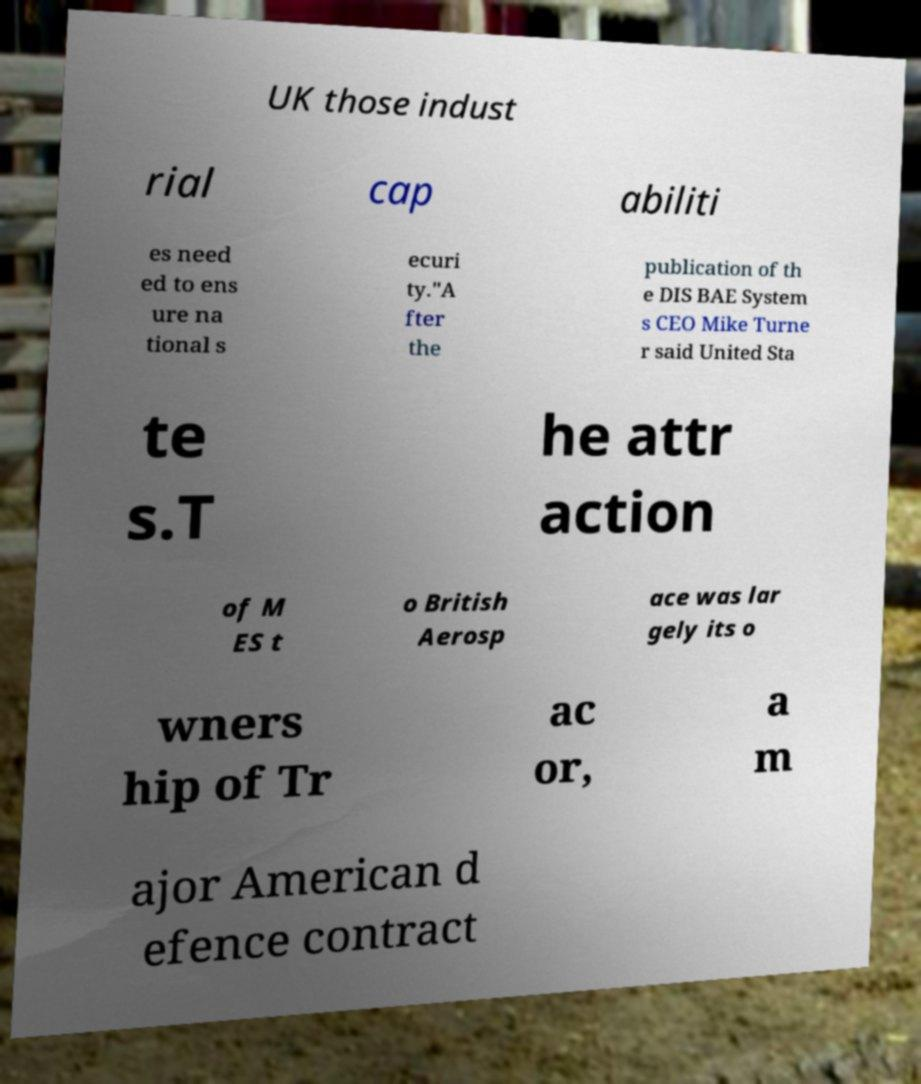For documentation purposes, I need the text within this image transcribed. Could you provide that? UK those indust rial cap abiliti es need ed to ens ure na tional s ecuri ty."A fter the publication of th e DIS BAE System s CEO Mike Turne r said United Sta te s.T he attr action of M ES t o British Aerosp ace was lar gely its o wners hip of Tr ac or, a m ajor American d efence contract 